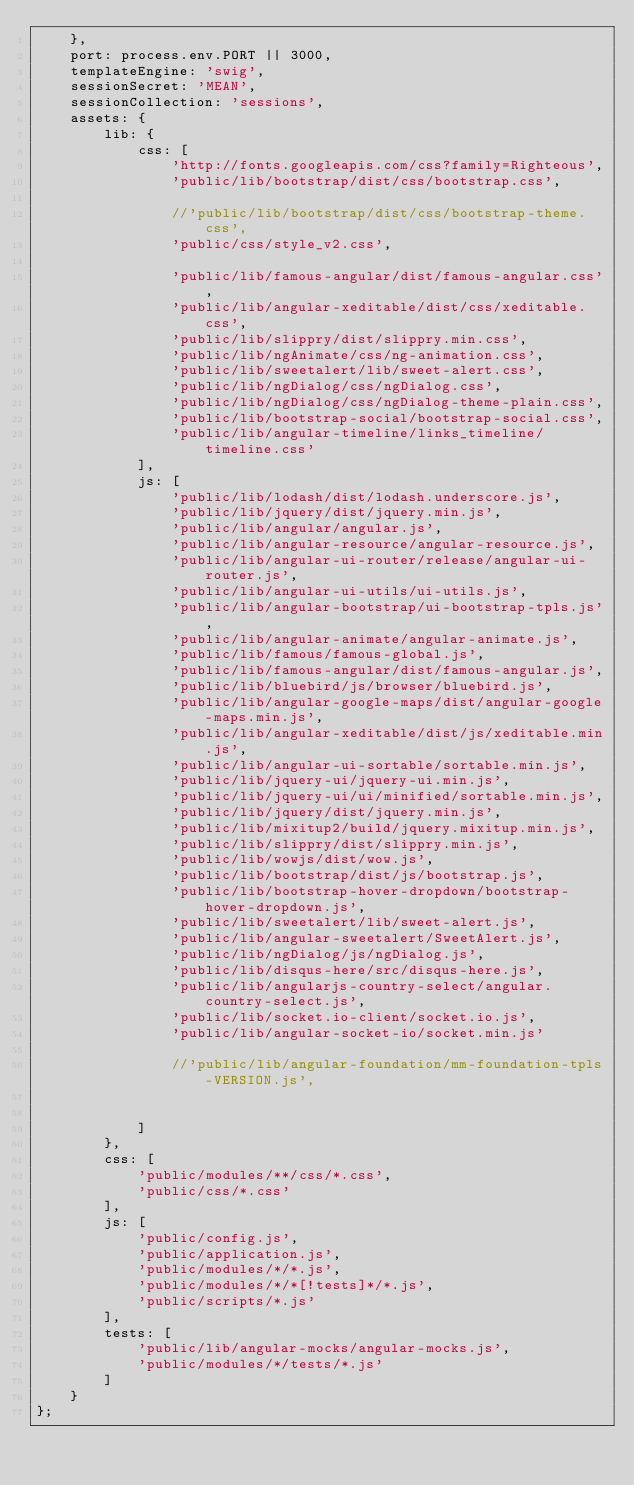Convert code to text. <code><loc_0><loc_0><loc_500><loc_500><_JavaScript_>	},
	port: process.env.PORT || 3000,
	templateEngine: 'swig',
	sessionSecret: 'MEAN',
	sessionCollection: 'sessions',
	assets: {
		lib: {
			css: [
                'http://fonts.googleapis.com/css?family=Righteous',
				'public/lib/bootstrap/dist/css/bootstrap.css',

				//'public/lib/bootstrap/dist/css/bootstrap-theme.css',
				'public/css/style_v2.css',

				'public/lib/famous-angular/dist/famous-angular.css',
				'public/lib/angular-xeditable/dist/css/xeditable.css',
				'public/lib/slippry/dist/slippry.min.css',
				'public/lib/ngAnimate/css/ng-animation.css',
				'public/lib/sweetalert/lib/sweet-alert.css',
				'public/lib/ngDialog/css/ngDialog.css',
				'public/lib/ngDialog/css/ngDialog-theme-plain.css',
				'public/lib/bootstrap-social/bootstrap-social.css',
				'public/lib/angular-timeline/links_timeline/timeline.css'
			],
			js: [
				'public/lib/lodash/dist/lodash.underscore.js',
				'public/lib/jquery/dist/jquery.min.js',
				'public/lib/angular/angular.js',
				'public/lib/angular-resource/angular-resource.js',
				'public/lib/angular-ui-router/release/angular-ui-router.js',
				'public/lib/angular-ui-utils/ui-utils.js',
				'public/lib/angular-bootstrap/ui-bootstrap-tpls.js',
				'public/lib/angular-animate/angular-animate.js',
				'public/lib/famous/famous-global.js',
				'public/lib/famous-angular/dist/famous-angular.js',
				'public/lib/bluebird/js/browser/bluebird.js',
				'public/lib/angular-google-maps/dist/angular-google-maps.min.js',
				'public/lib/angular-xeditable/dist/js/xeditable.min.js',
				'public/lib/angular-ui-sortable/sortable.min.js',
				'public/lib/jquery-ui/jquery-ui.min.js',
				'public/lib/jquery-ui/ui/minified/sortable.min.js',
				'public/lib/jquery/dist/jquery.min.js',
				'public/lib/mixitup2/build/jquery.mixitup.min.js',
				'public/lib/slippry/dist/slippry.min.js',
				'public/lib/wowjs/dist/wow.js',
				'public/lib/bootstrap/dist/js/bootstrap.js',
				'public/lib/bootstrap-hover-dropdown/bootstrap-hover-dropdown.js',
				'public/lib/sweetalert/lib/sweet-alert.js',
				'public/lib/angular-sweetalert/SweetAlert.js',
				'public/lib/ngDialog/js/ngDialog.js',
				'public/lib/disqus-here/src/disqus-here.js',
				'public/lib/angularjs-country-select/angular.country-select.js',
				'public/lib/socket.io-client/socket.io.js',
				'public/lib/angular-socket-io/socket.min.js'

				//'public/lib/angular-foundation/mm-foundation-tpls-VERSION.js',


			]
		},
		css: [
			'public/modules/**/css/*.css',
			'public/css/*.css'
		],
		js: [
			'public/config.js',
			'public/application.js',
			'public/modules/*/*.js',
			'public/modules/*/*[!tests]*/*.js',
			'public/scripts/*.js'
		],
		tests: [
			'public/lib/angular-mocks/angular-mocks.js',
			'public/modules/*/tests/*.js'
		]
	}
};
</code> 